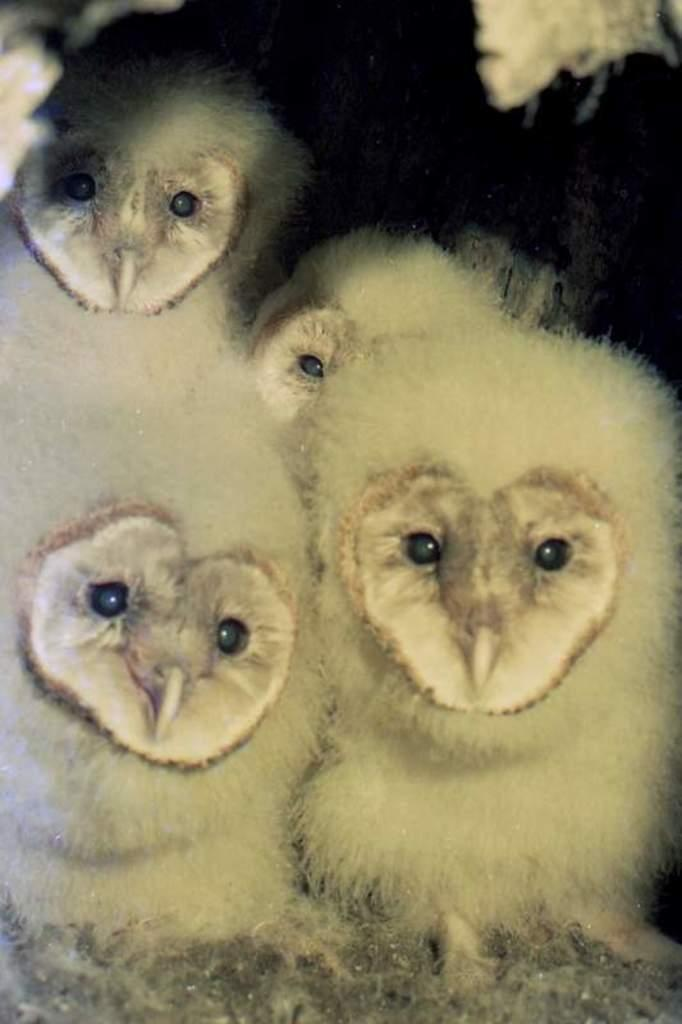What type of animals can be seen in the image? Birds can be seen in the image. What is the color of the background in the image? The background of the image is dark. What type of meal is being prepared on the square sticks in the image? There is no meal or sticks present in the image; it features birds with a dark background. 